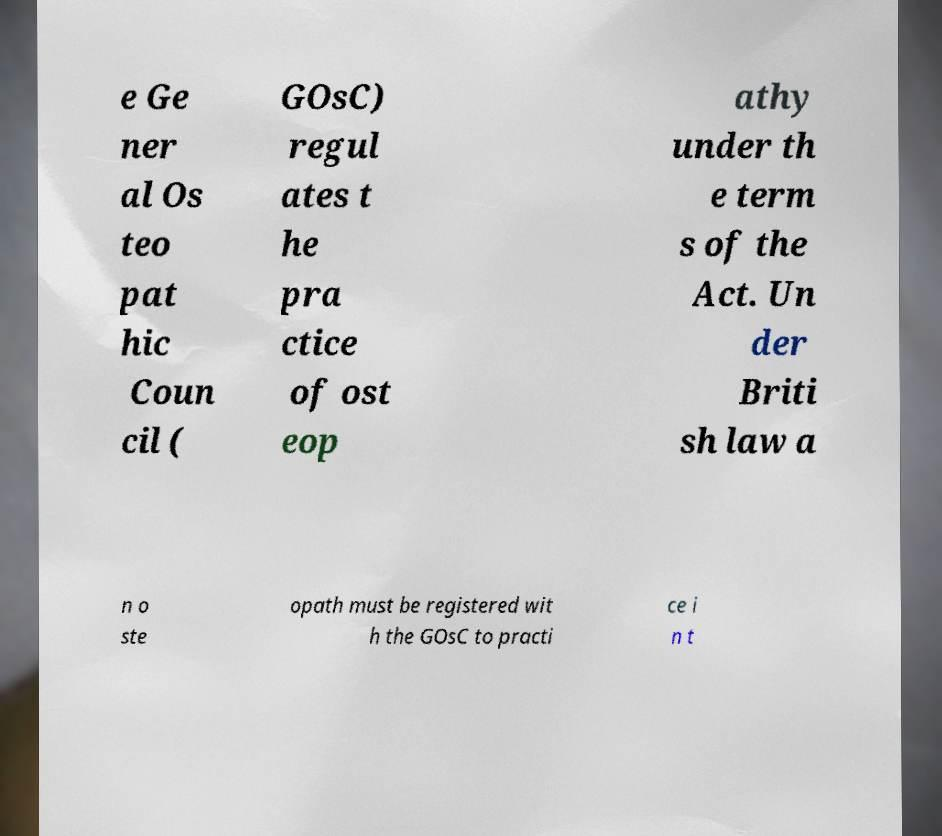I need the written content from this picture converted into text. Can you do that? e Ge ner al Os teo pat hic Coun cil ( GOsC) regul ates t he pra ctice of ost eop athy under th e term s of the Act. Un der Briti sh law a n o ste opath must be registered wit h the GOsC to practi ce i n t 